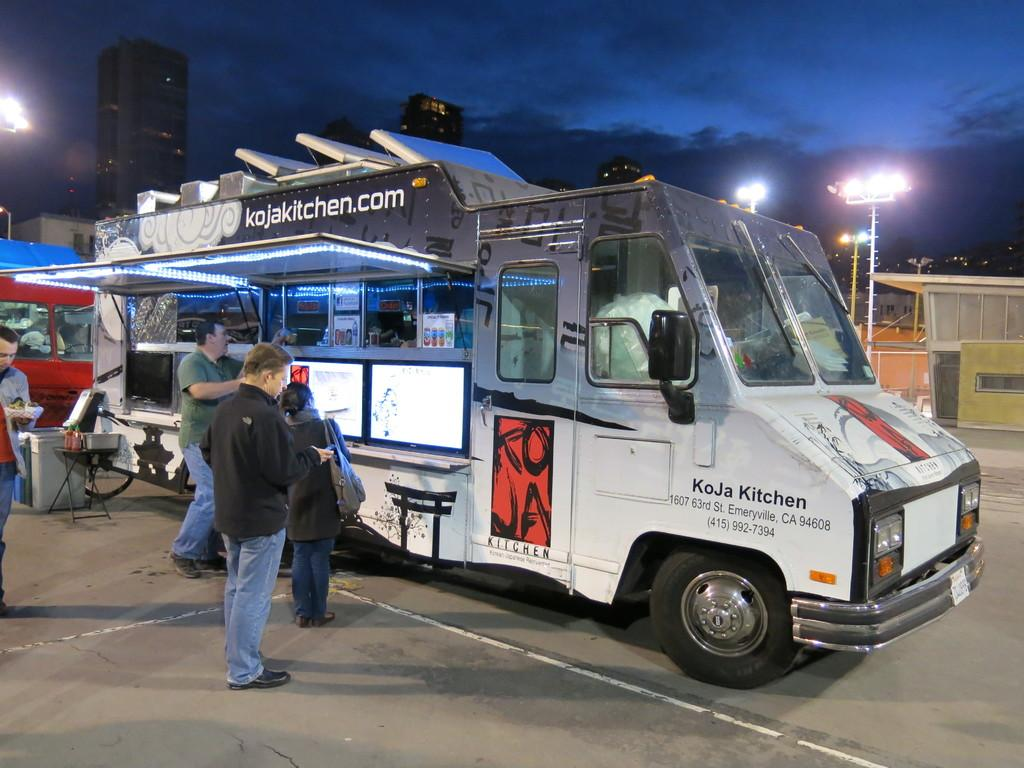<image>
Describe the image concisely. A food truck that is run by KoJa Kitchens in St. Emeryville, California. 